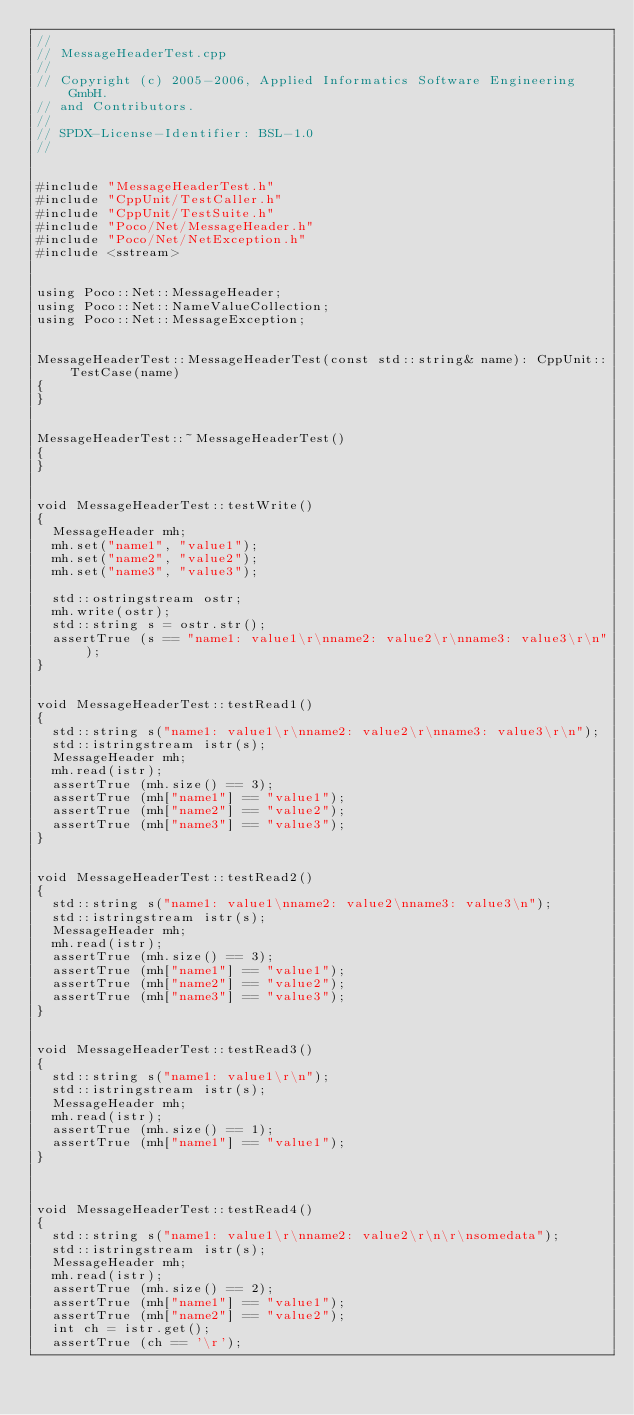Convert code to text. <code><loc_0><loc_0><loc_500><loc_500><_C++_>//
// MessageHeaderTest.cpp
//
// Copyright (c) 2005-2006, Applied Informatics Software Engineering GmbH.
// and Contributors.
//
// SPDX-License-Identifier:	BSL-1.0
//


#include "MessageHeaderTest.h"
#include "CppUnit/TestCaller.h"
#include "CppUnit/TestSuite.h"
#include "Poco/Net/MessageHeader.h"
#include "Poco/Net/NetException.h"
#include <sstream>


using Poco::Net::MessageHeader;
using Poco::Net::NameValueCollection;
using Poco::Net::MessageException;


MessageHeaderTest::MessageHeaderTest(const std::string& name): CppUnit::TestCase(name)
{
}


MessageHeaderTest::~MessageHeaderTest()
{
}


void MessageHeaderTest::testWrite()
{
	MessageHeader mh;
	mh.set("name1", "value1");
	mh.set("name2", "value2");
	mh.set("name3", "value3");
	
	std::ostringstream ostr;
	mh.write(ostr);
	std::string s = ostr.str();
	assertTrue (s == "name1: value1\r\nname2: value2\r\nname3: value3\r\n");
}


void MessageHeaderTest::testRead1()
{
	std::string s("name1: value1\r\nname2: value2\r\nname3: value3\r\n");
	std::istringstream istr(s);
	MessageHeader mh;
	mh.read(istr);
	assertTrue (mh.size() == 3);
	assertTrue (mh["name1"] == "value1");
	assertTrue (mh["name2"] == "value2");
	assertTrue (mh["name3"] == "value3");
}


void MessageHeaderTest::testRead2()
{
	std::string s("name1: value1\nname2: value2\nname3: value3\n");
	std::istringstream istr(s);
	MessageHeader mh;
	mh.read(istr);
	assertTrue (mh.size() == 3);
	assertTrue (mh["name1"] == "value1");
	assertTrue (mh["name2"] == "value2");
	assertTrue (mh["name3"] == "value3");
}


void MessageHeaderTest::testRead3()
{
	std::string s("name1: value1\r\n");
	std::istringstream istr(s);
	MessageHeader mh;
	mh.read(istr);
	assertTrue (mh.size() == 1);
	assertTrue (mh["name1"] == "value1");
}



void MessageHeaderTest::testRead4()
{
	std::string s("name1: value1\r\nname2: value2\r\n\r\nsomedata");
	std::istringstream istr(s);
	MessageHeader mh;
	mh.read(istr);
	assertTrue (mh.size() == 2);
	assertTrue (mh["name1"] == "value1");
	assertTrue (mh["name2"] == "value2");
	int ch = istr.get();
	assertTrue (ch == '\r');</code> 